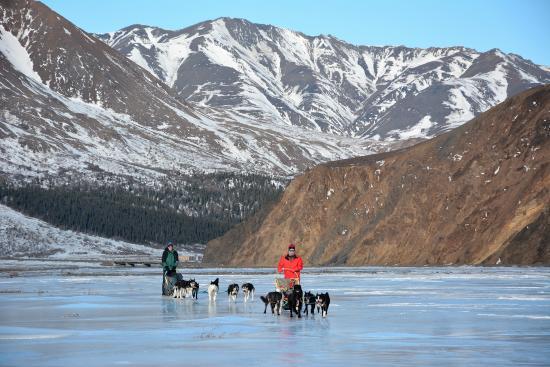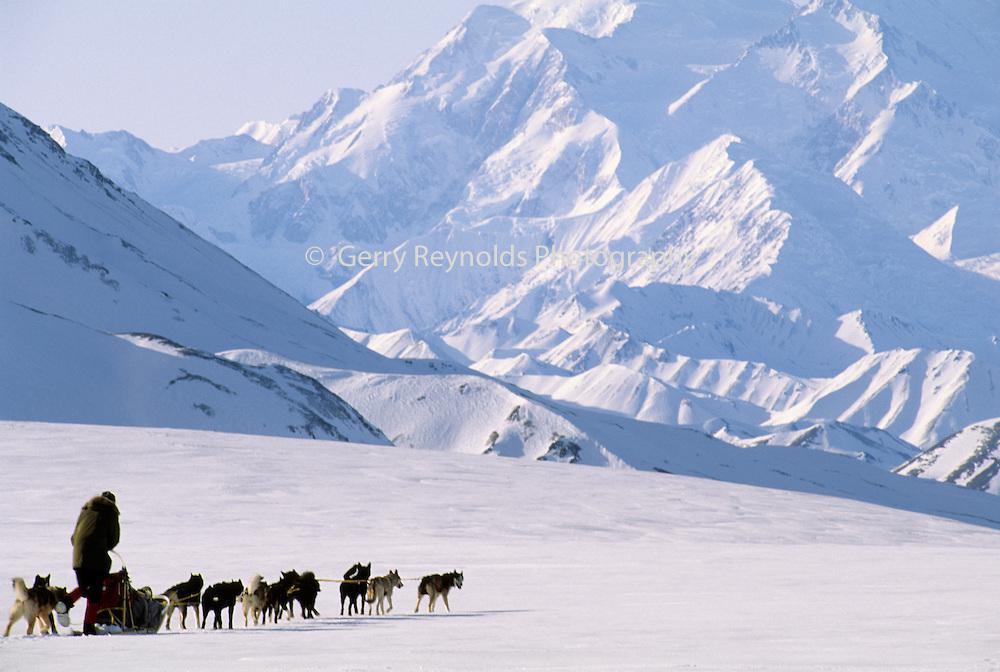The first image is the image on the left, the second image is the image on the right. Evaluate the accuracy of this statement regarding the images: "One image shows a sled driver standing on the right, behind a red sled that's in profile, with a team of leftward-aimed dogs hitched to it.". Is it true? Answer yes or no. No. The first image is the image on the left, the second image is the image on the right. Assess this claim about the two images: "There is exactly one sled driver visible.". Correct or not? Answer yes or no. No. 